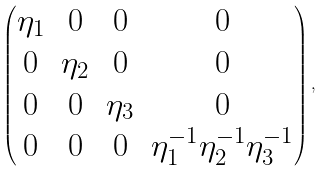<formula> <loc_0><loc_0><loc_500><loc_500>\begin{pmatrix} \eta _ { 1 } & 0 & 0 & 0 \\ 0 & \eta _ { 2 } & 0 & 0 \\ 0 & 0 & \eta _ { 3 } & 0 \\ 0 & 0 & 0 & \eta _ { 1 } ^ { - 1 } \eta _ { 2 } ^ { - 1 } \eta _ { 3 } ^ { - 1 } \end{pmatrix} ,</formula> 